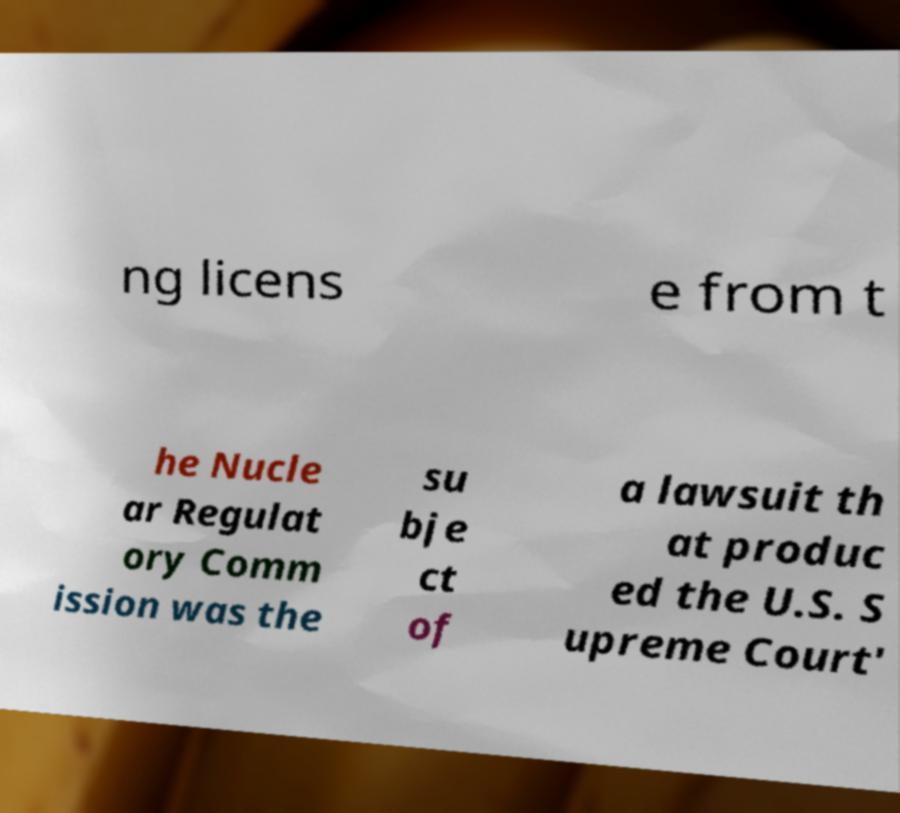There's text embedded in this image that I need extracted. Can you transcribe it verbatim? ng licens e from t he Nucle ar Regulat ory Comm ission was the su bje ct of a lawsuit th at produc ed the U.S. S upreme Court' 